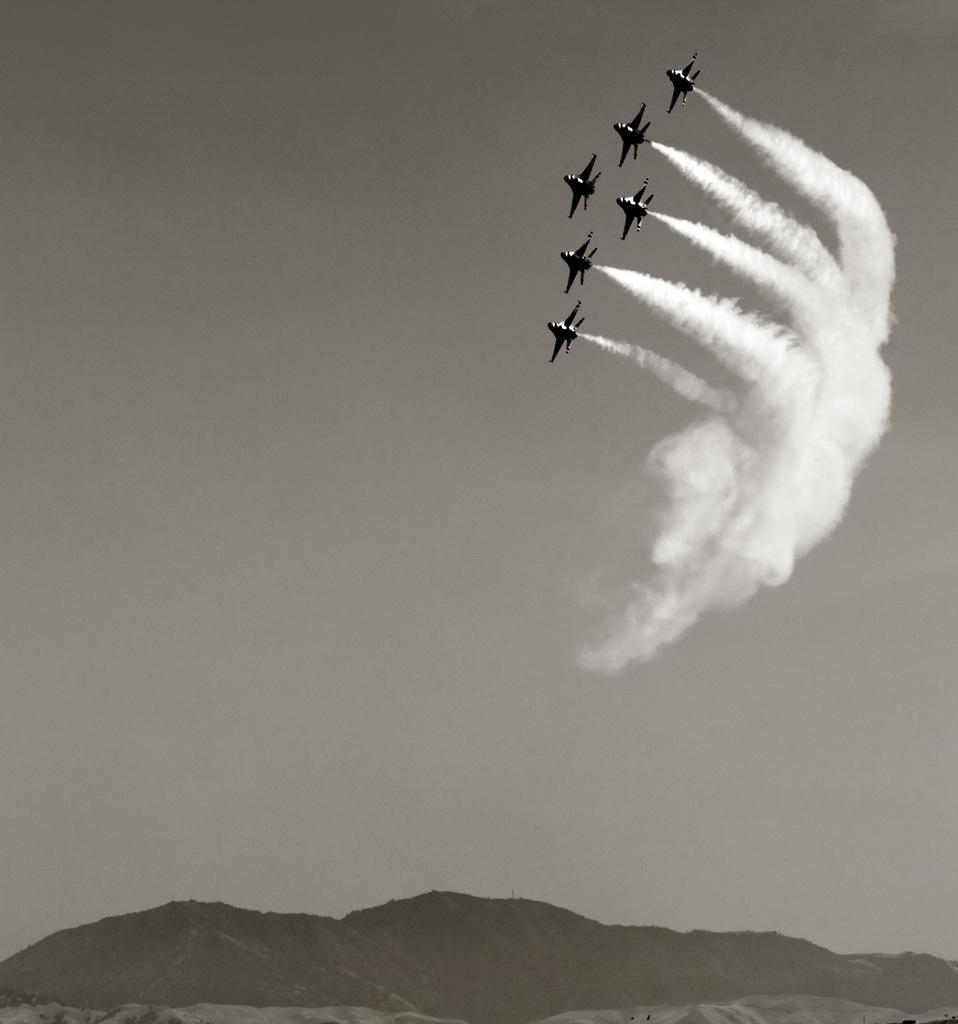How would you summarize this image in a sentence or two? In this picture we can see few planes in the air and we can see smoke, at the bottom of the image we can see hills. 